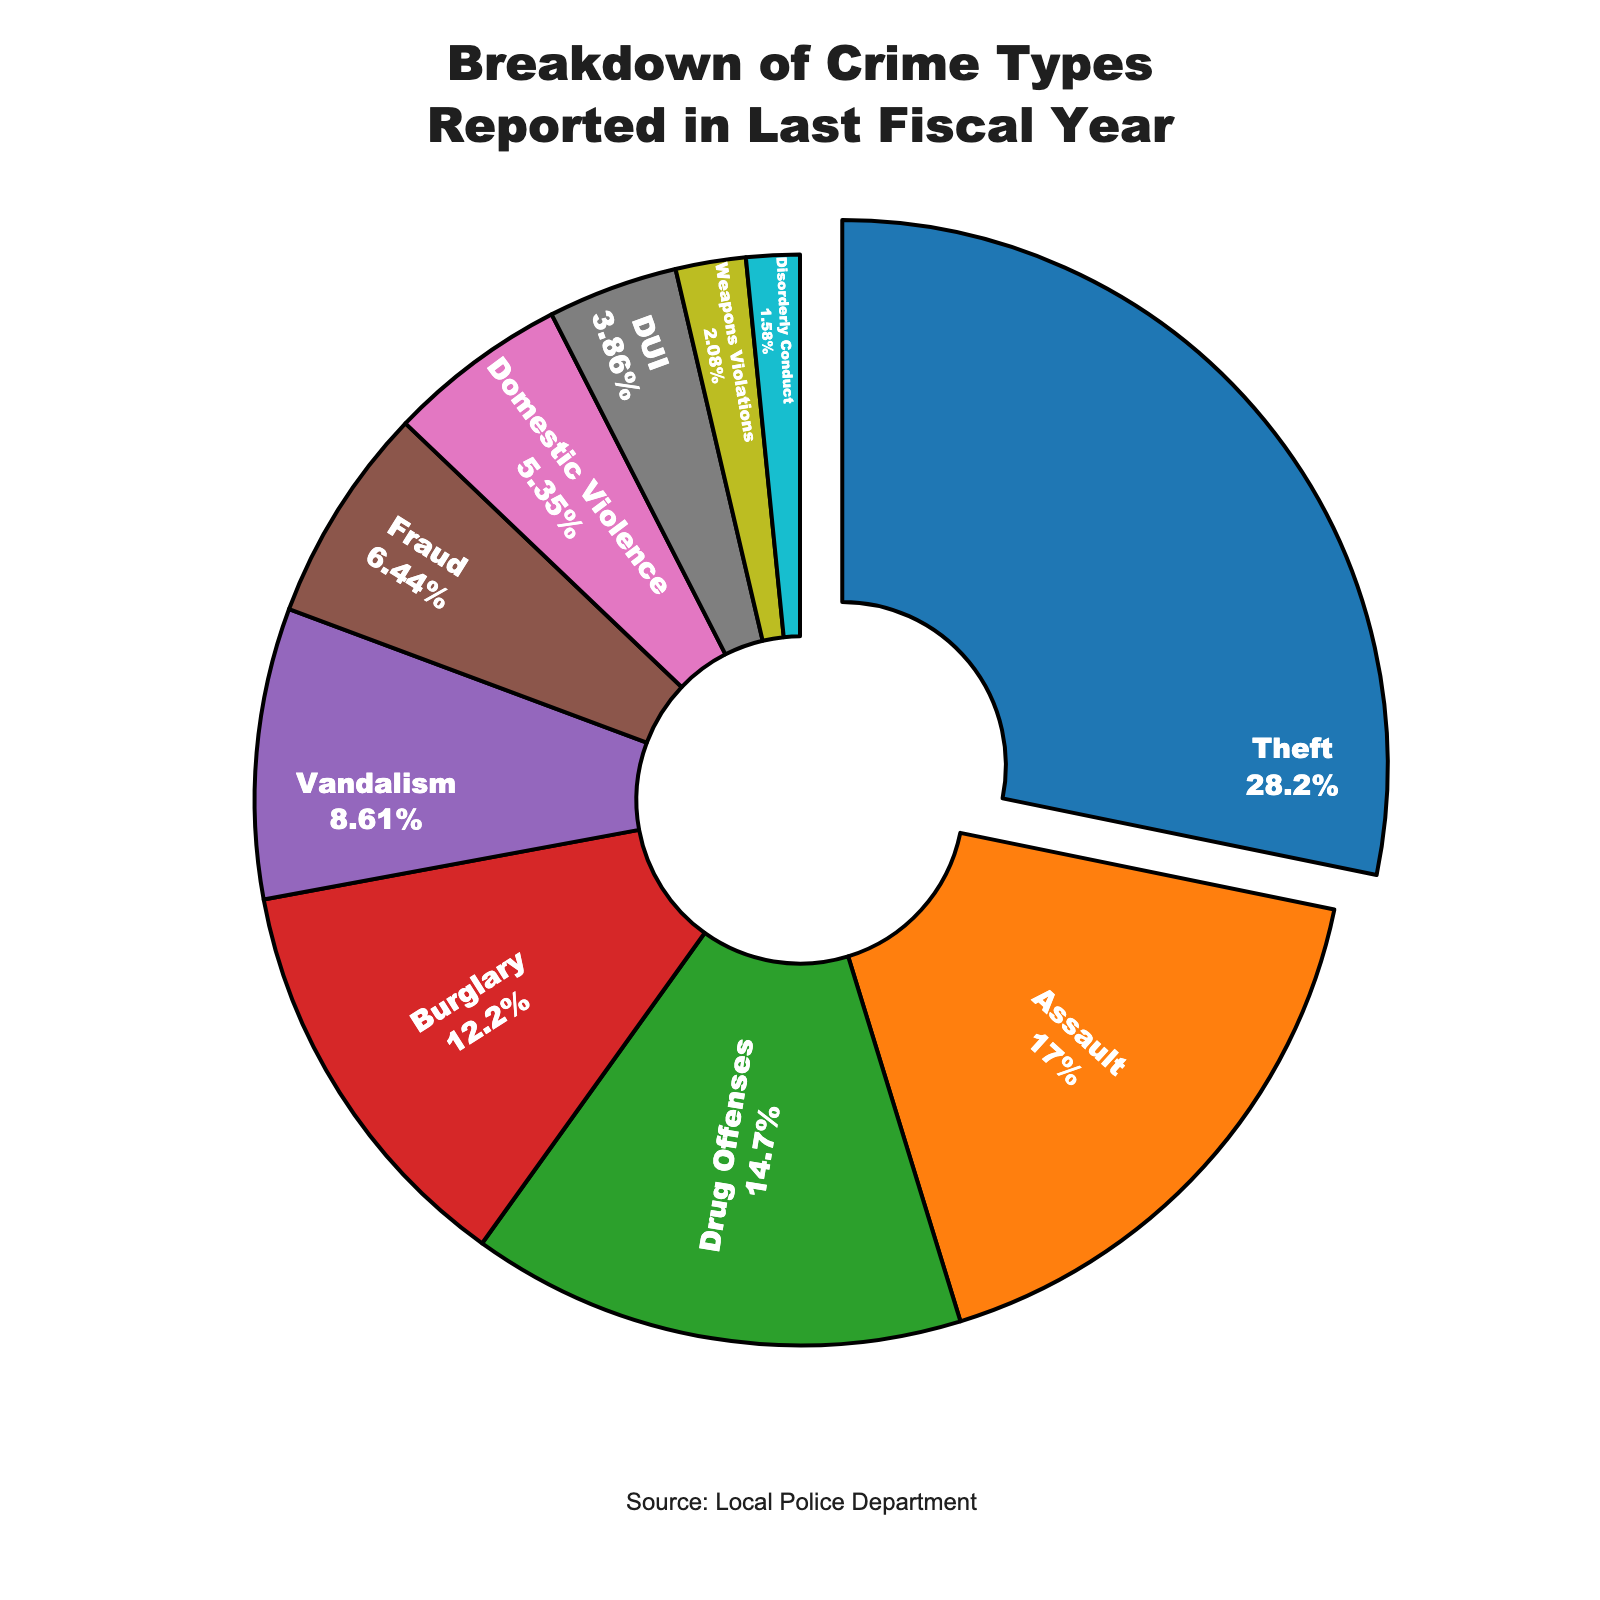What is the most frequently reported crime type? The figure shows a breakdown of crime types with their respective percentages. The largest segment in the pie chart is theft, which has the highest reported percentage.
Answer: Theft Which crime type has the lowest percentage of reports? Examining the pie chart, the smallest segment corresponds to disorderly conduct, which has the lowest percentage of reports.
Answer: Disorderly Conduct How much more frequently is theft reported compared to burglary? The percentage of theft reports is 28.5%, while the percentage of burglary reports is 12.3%. Subtracting these values, 28.5% - 12.3% = 16.2%.
Answer: 16.2% What is the combined percentage of property-related crimes (theft and burglary)? Adding the percentages of theft (28.5%) and burglary (12.3%) gives a combined total of 28.5% + 12.3% = 40.8%.
Answer: 40.8% How does the report rate of assault compare to that of fraud? The figure shows that assault has a percentage of 17.2%, and fraud has a percentage of 6.5%. To compare, 17.2% is greater than 6.5%.
Answer: Assault is greater What percentage of the total reports are accounted for by vandalism and drug offenses combined? The figure indicates that vandalism and drug offenses have percentages of 8.7% and 14.8% respectively. Adding them gives 8.7% + 14.8% = 23.5%.
Answer: 23.5% Which color represents domestic violence in the pie chart? Domestic violence is represented by one of the colored segments. Given that the color details translate naturally, we observe that domestic violence's percentage is linked to a distinct color which can be identified within the visual.
Answer: Depends on the chart (e.g., pink or a specific color based on the visual representation) What is the combined percentage of all crimes reported under 10%? Summing the percentages under 10%: vandalism (8.7%), fraud (6.5%), domestic violence (5.4%), DUI (3.9%), weapons violations (2.1%), disorderly conduct (1.6%), gives 8.7% + 6.5% + 5.4% + 3.9% + 2.1% + 1.6% = 28.2%.
Answer: 28.2% 